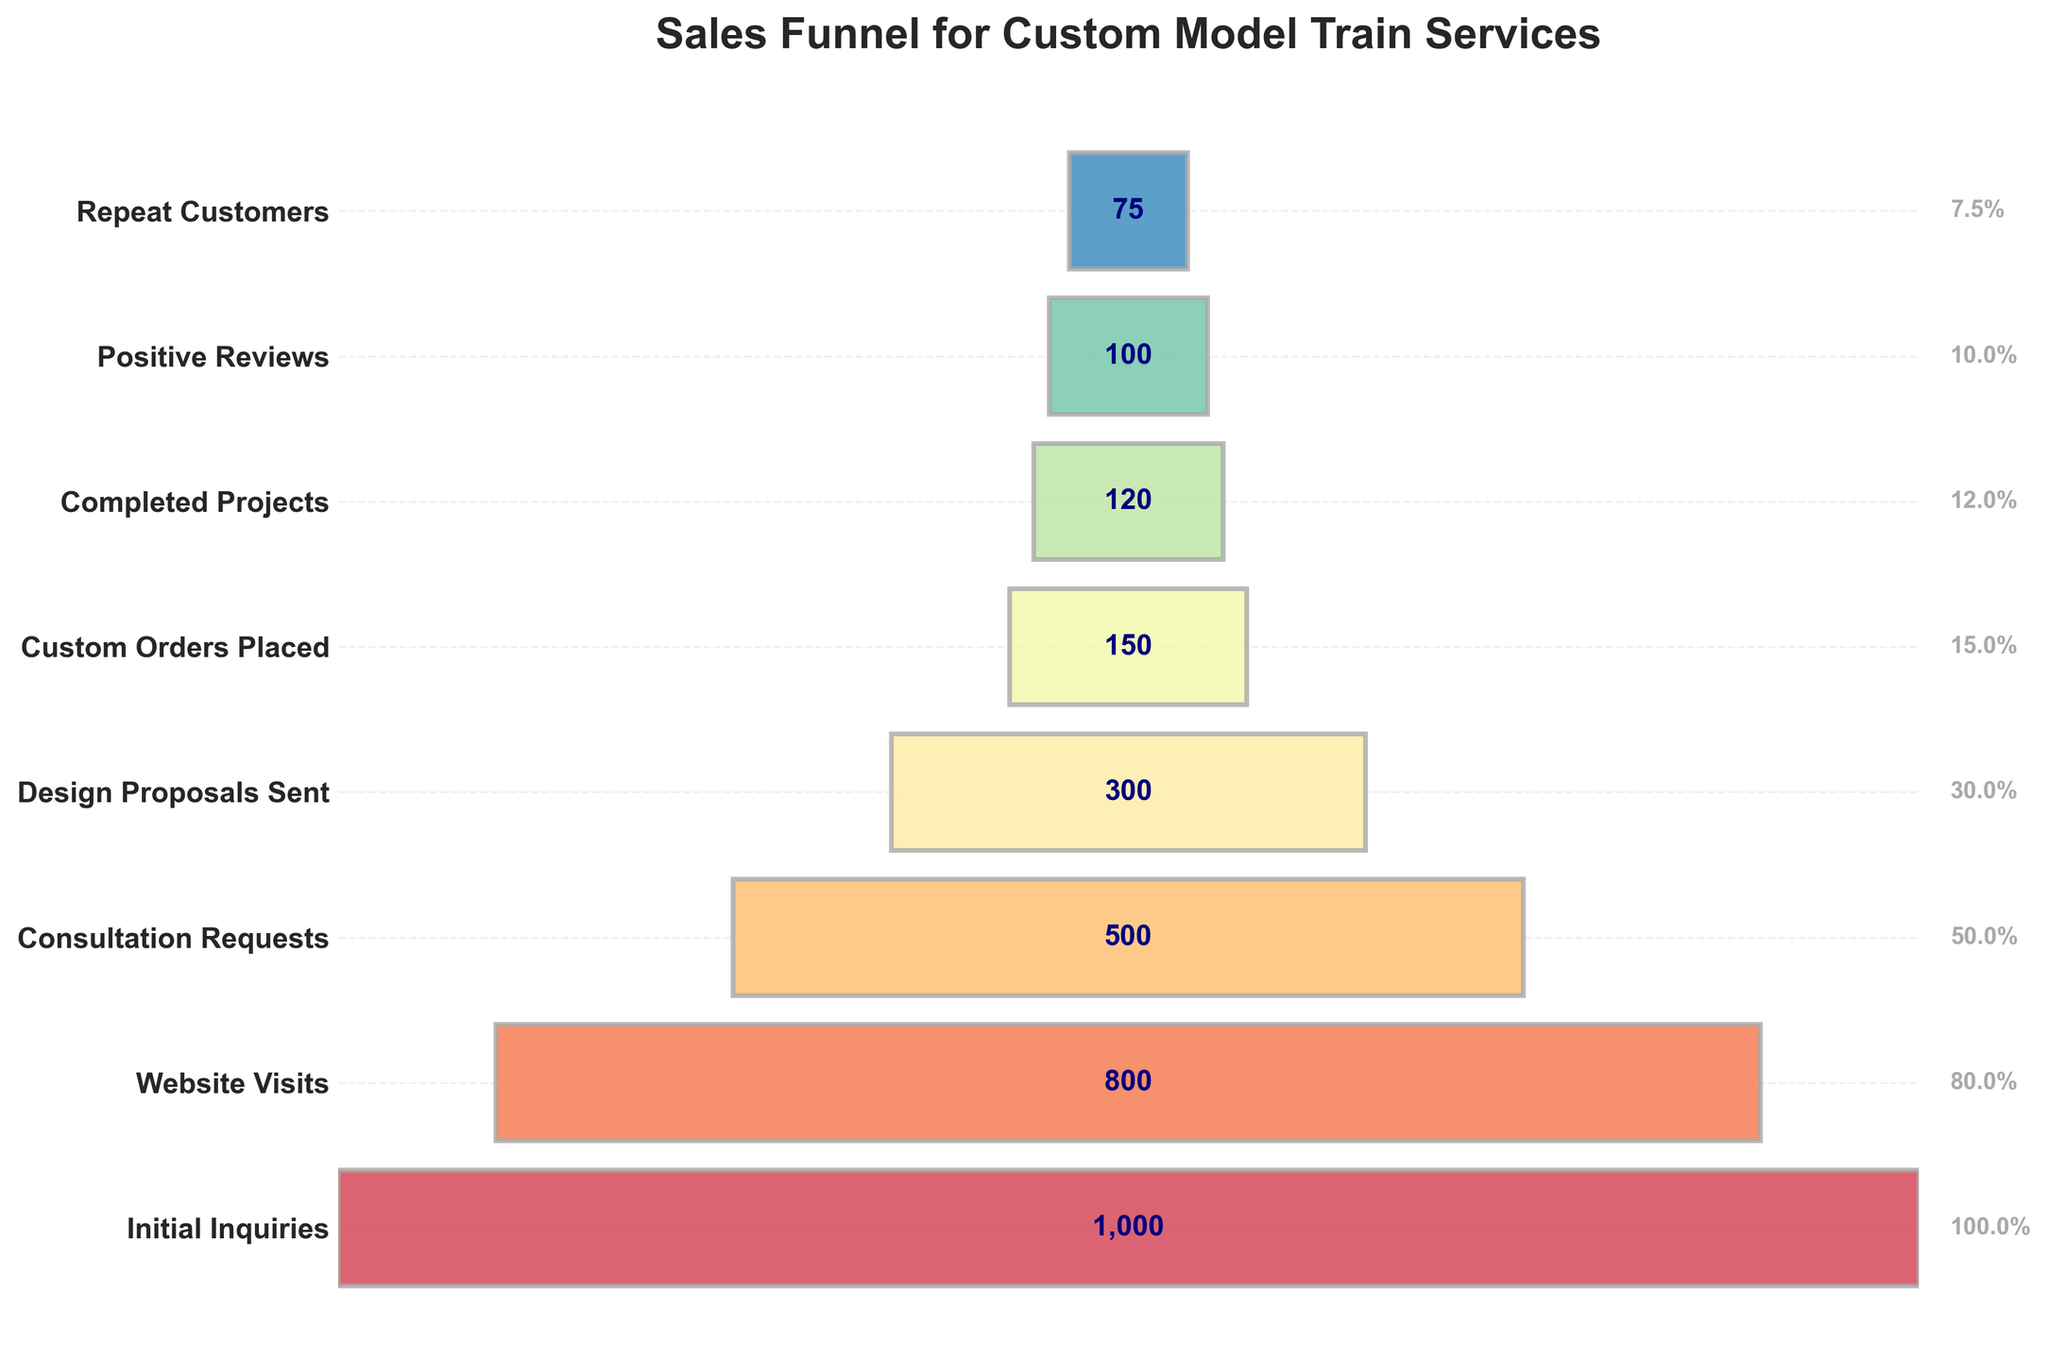What's the title of the funnel chart? The title of the funnel chart is prominently displayed at the top of the figure. It provides the context for the data visualized in the chart. In this case, it reads "Sales Funnel for Custom Model Train Services."
Answer: Sales Funnel for Custom Model Train Services How many stages are there in the sales funnel? The number of stages in the funnel chart can be determined by counting the horizontal bars. Each bar represents a stage. Here, there are 8 stages listed from 'Initial Inquiries' to 'Repeat Customers.'
Answer: 8 What is the first stage in the funnel and how many counts does it have? The first stage is labeled at the top of the funnel chart, and the count is displayed within the bar. The first stage in this funnel is 'Initial Inquiries' with a count of 1,000.
Answer: Initial Inquiries, 1,000 How many customers reach the 'Completed Projects' stage? To find this, look at the 'Completed Projects' stage in the funnel chart and check the count displayed within the bar, which shows 120.
Answer: 120 Which stage has the lowest count, and what is it? By observing the funnel chart from top to bottom, we can identify that the last stage usually has the lowest count. The last stage here is 'Repeat Customers' with a count of 75.
Answer: Repeat Customers, 75 What percentage of the initial inquiries become custom orders placed? Calculate the percentage by dividing the count for 'Custom Orders Placed' by the count for 'Initial Inquiries' and then multiplying by 100. (150 / 1000) * 100 = 15%.
Answer: 15% What is the difference in count between 'Website Visits' and 'Consultation Requests'? Subtract the count of 'Consultation Requests' from 'Website Visits' to find the difference. 800 - 500 = 300.
Answer: 300 What stage follows 'Design Proposals Sent' and how many counts does it have? After 'Design Proposals Sent' in the sequence, the next stage is 'Custom Orders Placed.' The count for this stage is 150, as indicated in the funnel chart.
Answer: Custom Orders Placed, 150 How do the counts for 'Positive Reviews' and 'Repeat Customers' compare? By looking at the funnel chart, observe the counts for 'Positive Reviews' (100) and 'Repeat Customers' (75). 'Positive Reviews' has a count greater than 'Repeat Customers.'
Answer: Positive Reviews > Repeat Customers What are the counts for the intermediate stage with exactly half the counts of the initial stage 'Initial Inquiries'? Identify the stage with counts equal to half of 1,000 (Initial Inquiries), which is 500. The stage with this count is 'Consultation Requests.'
Answer: Consultation Requests, 500 